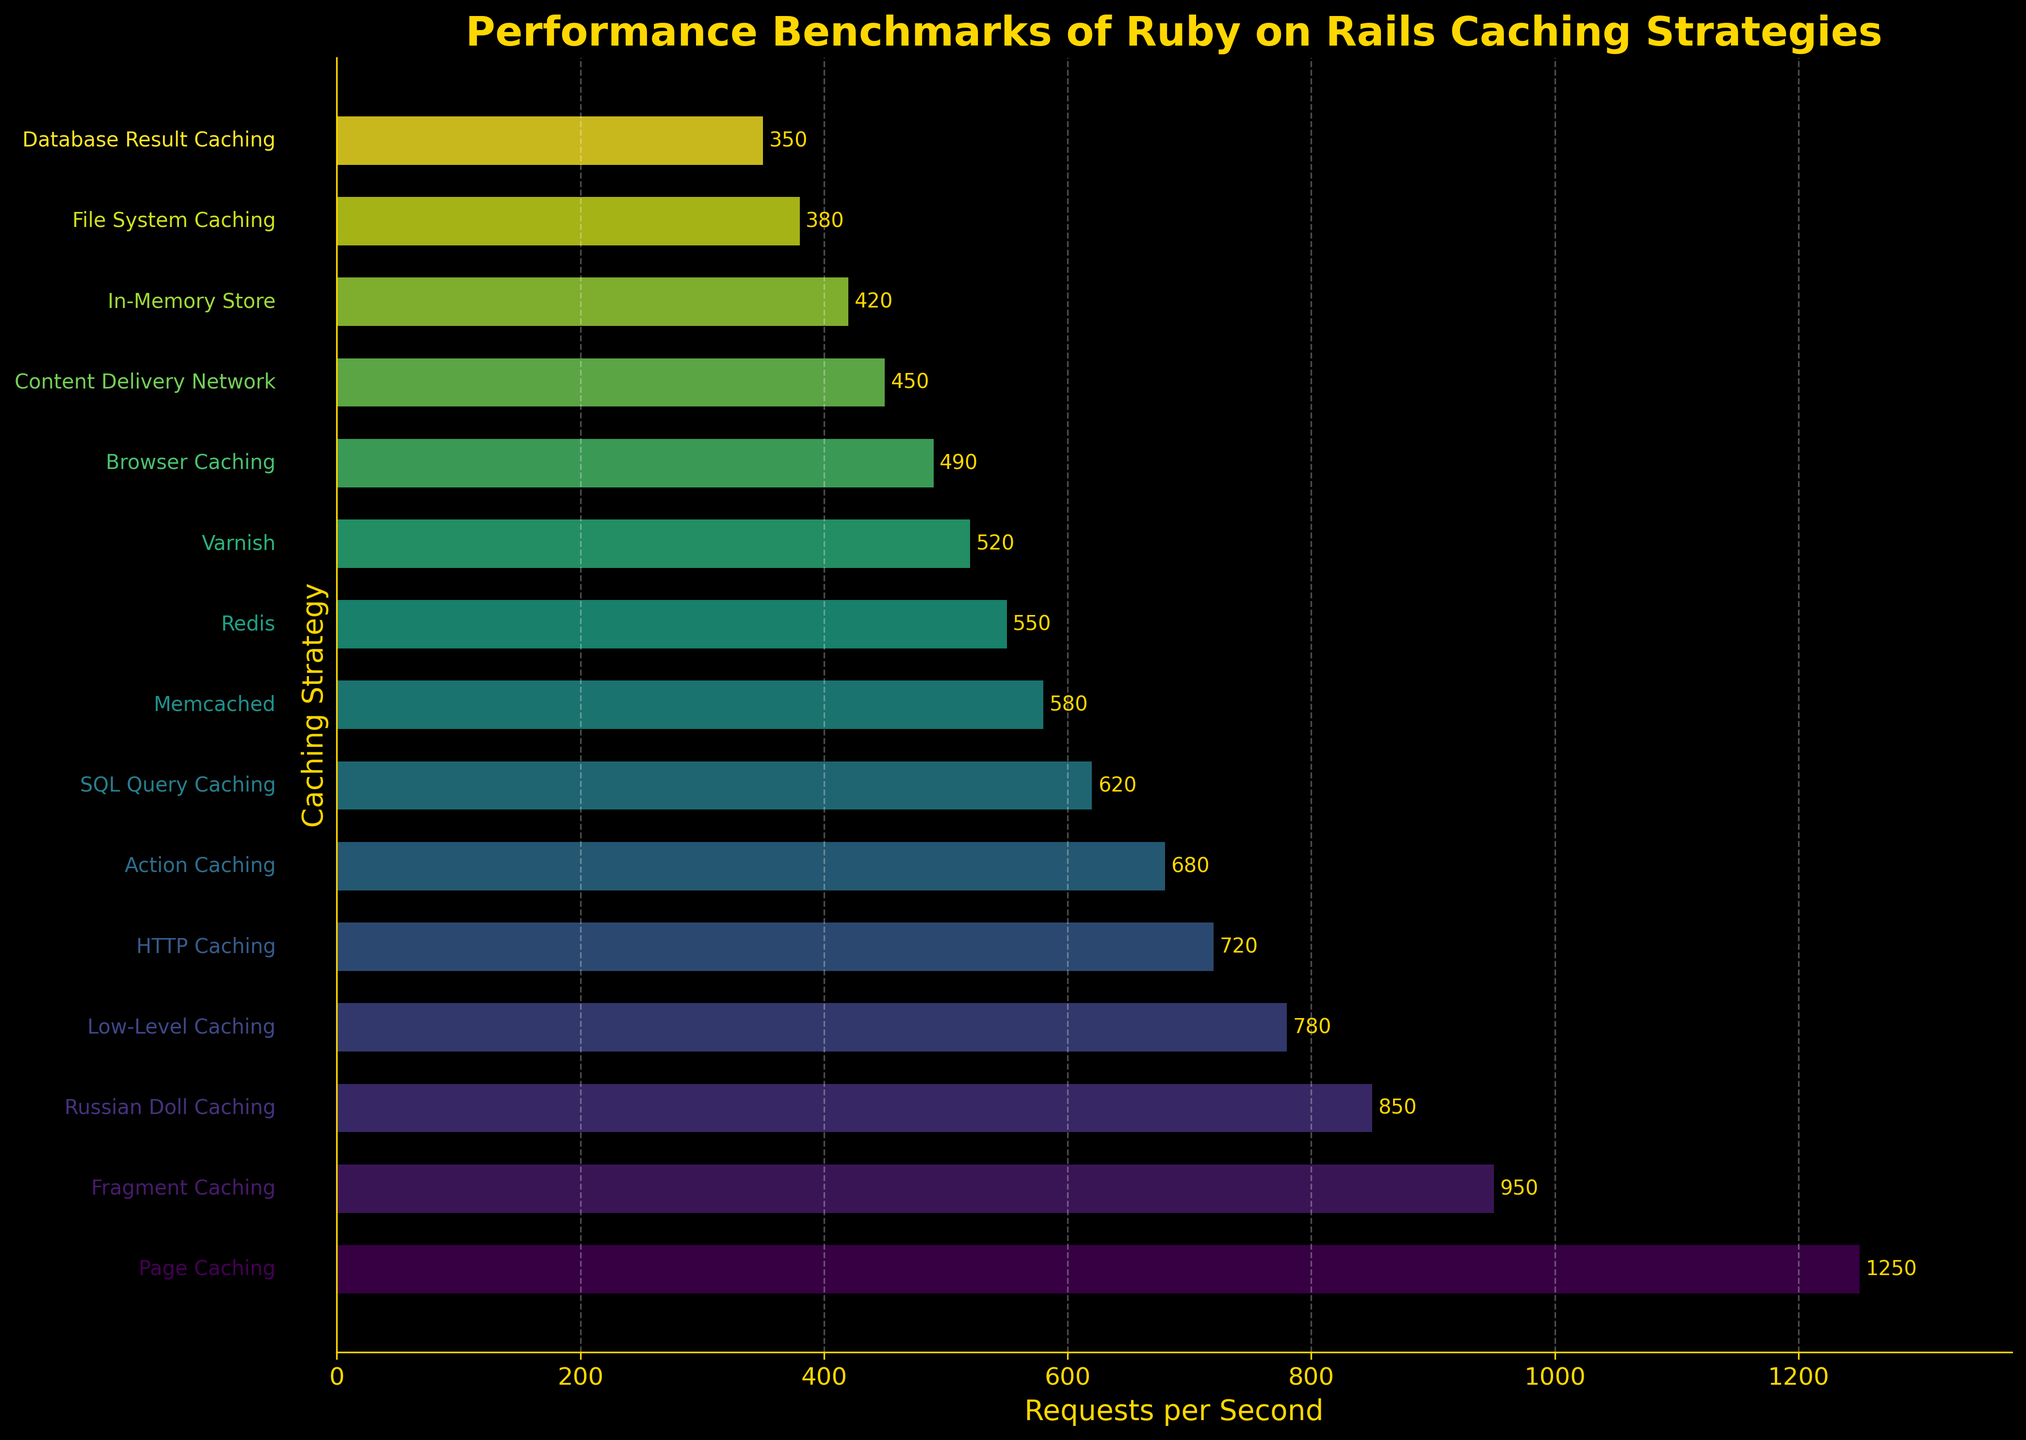What caching strategy has the highest number of requests per second? Page Caching has the highest bar, representing the highest number of requests per second.
Answer: Page Caching What is the difference in requests per second between Page Caching and Redis? Page Caching has 1250 requests per second and Redis has 550 requests per second. The difference is 1250 - 550 = 700.
Answer: 700 Which two caching strategies are separated by the smallest difference in requests per second, and what is that difference? SQL Query Caching has 620 requests per second and Memcached has 580 requests per second. The difference is 620 - 580 = 40, which is the smallest difference in the data.
Answer: SQL Query Caching and Memcached, 40 What's the total number of requests per second for the bottom three strategies? The bottom three strategies are File System Caching (380), Database Result Caching (350), and In-Memory Store (420). Total is 380 + 350 + 420 = 1150.
Answer: 1150 How many strategies have requests per second more than 800? Page Caching (1250), Fragment Caching (950), and Russian Doll Caching (850) are the strategies with more than 800 requests per second, making the count 3.
Answer: 3 Which caching strategy is in the middle of the ranking based on requests per second? There are 15 strategies, the middle one (8th) in the ranked order is Memcached with 580 requests per second.
Answer: Memcached Which strategy has a lighter color than Content Delivery Network but darker than Browser Caching? Varnish has a lighter color than Content Delivery Network (450) but darker than Browser Caching (490).
Answer: Varnish What is the average number of requests per second across all strategies? Sum of requests per second = 1250 + 950 + 850 + 780 + 720 + 680 + 620 + 580 + 550 + 520 + 490 + 450 + 420 + 380 + 350 = 9590. Average is 9590 / 15 ≈ 639.33.
Answer: 639.33 How many strategies have requests per second fewer than 600? Memcached (580), Redis (550), Varnish (520), Browser Caching (490), Content Delivery Network (450), In-Memory Store (420), File System Caching (380), and Database Result Caching (350) have fewer than 600 requests per second. Count is 8.
Answer: 8 Which caching strategies' requests per second are within 10 requests of each other? No two caching strategies' requests per second are within 10 requests of each other. The closest pairs have differences larger than 10.
Answer: None 